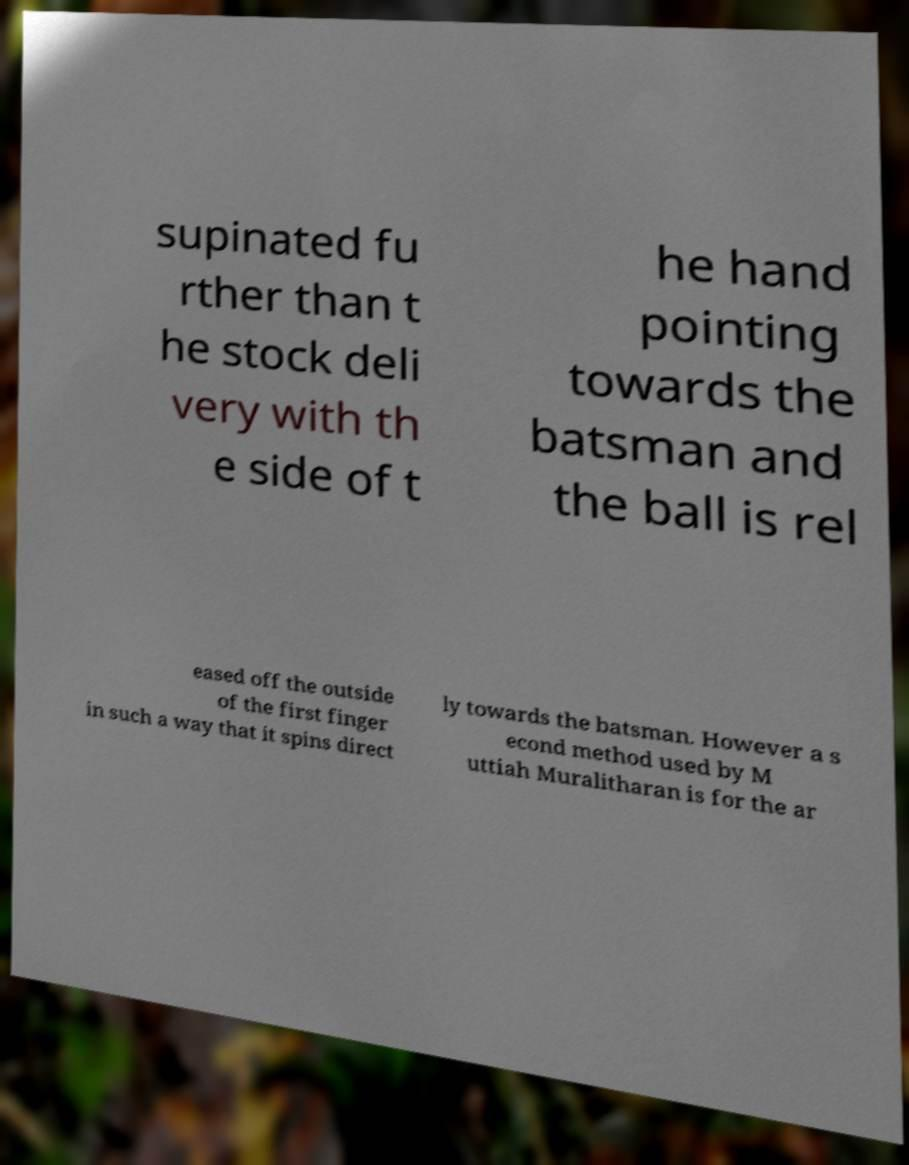What messages or text are displayed in this image? I need them in a readable, typed format. supinated fu rther than t he stock deli very with th e side of t he hand pointing towards the batsman and the ball is rel eased off the outside of the first finger in such a way that it spins direct ly towards the batsman. However a s econd method used by M uttiah Muralitharan is for the ar 